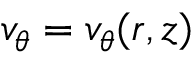<formula> <loc_0><loc_0><loc_500><loc_500>v _ { \theta } = v _ { \theta } ( r , z )</formula> 